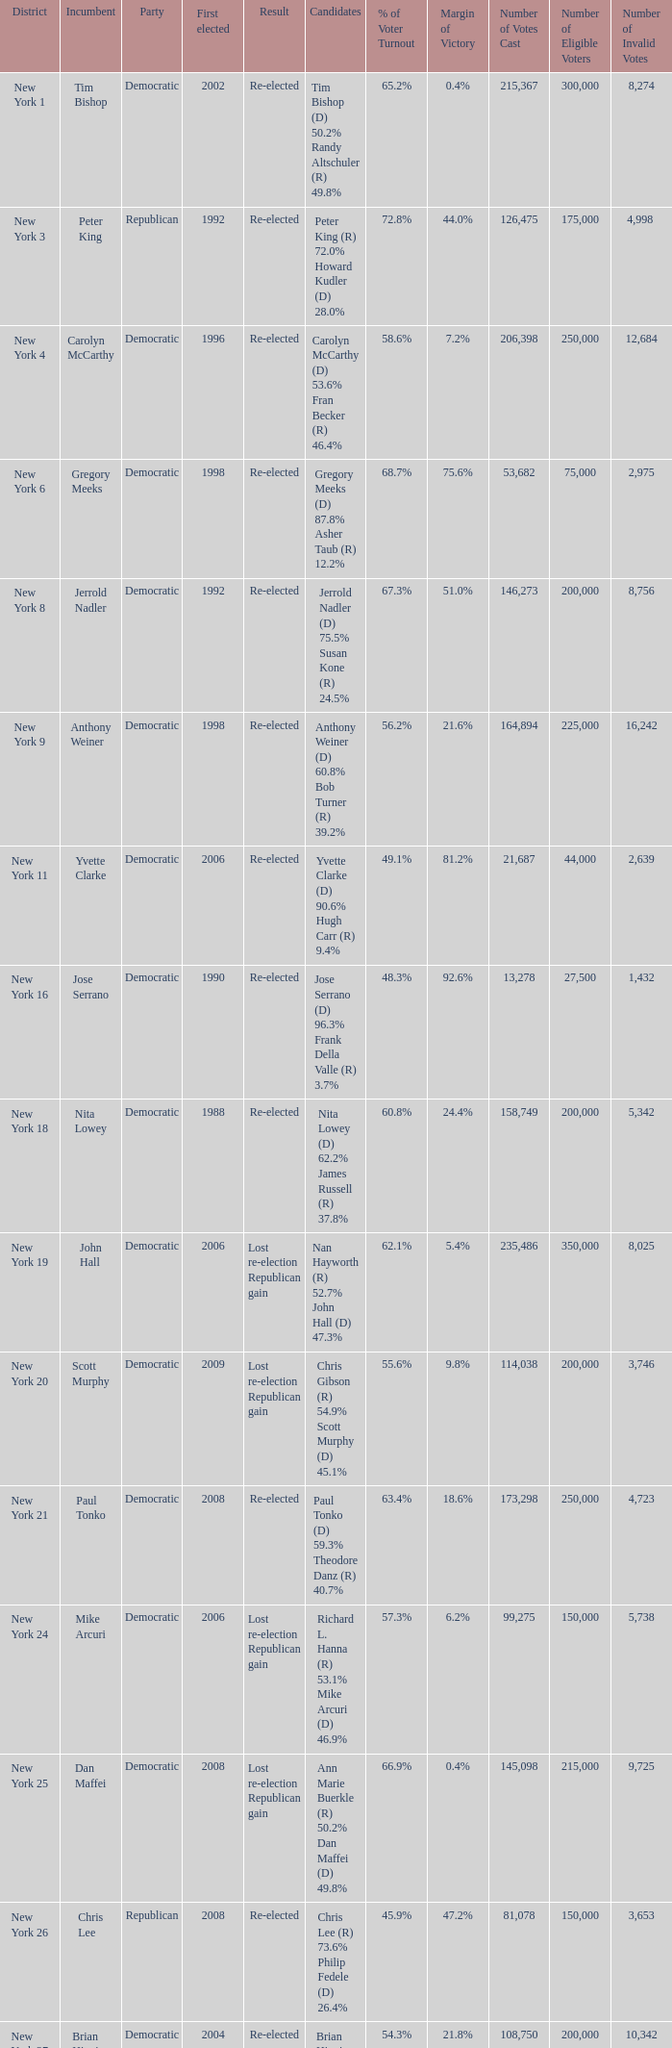Name the number of party for richard l. hanna (r) 53.1% mike arcuri (d) 46.9% 1.0. 